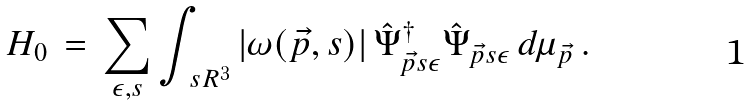Convert formula to latex. <formula><loc_0><loc_0><loc_500><loc_500>H _ { 0 } \, = \, \sum _ { \epsilon , s } \int _ { \ s R ^ { 3 } } | \omega ( \vec { p } , s ) | \, \hat { \Psi } ^ { \dagger } _ { \vec { p } s \epsilon } \hat { \Psi } _ { \vec { p } s \epsilon } \, d \mu _ { \vec { p } } \, .</formula> 